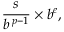Convert formula to latex. <formula><loc_0><loc_0><loc_500><loc_500>{ \frac { s } { b ^ { \, p - 1 } } } \times b ^ { e } ,</formula> 